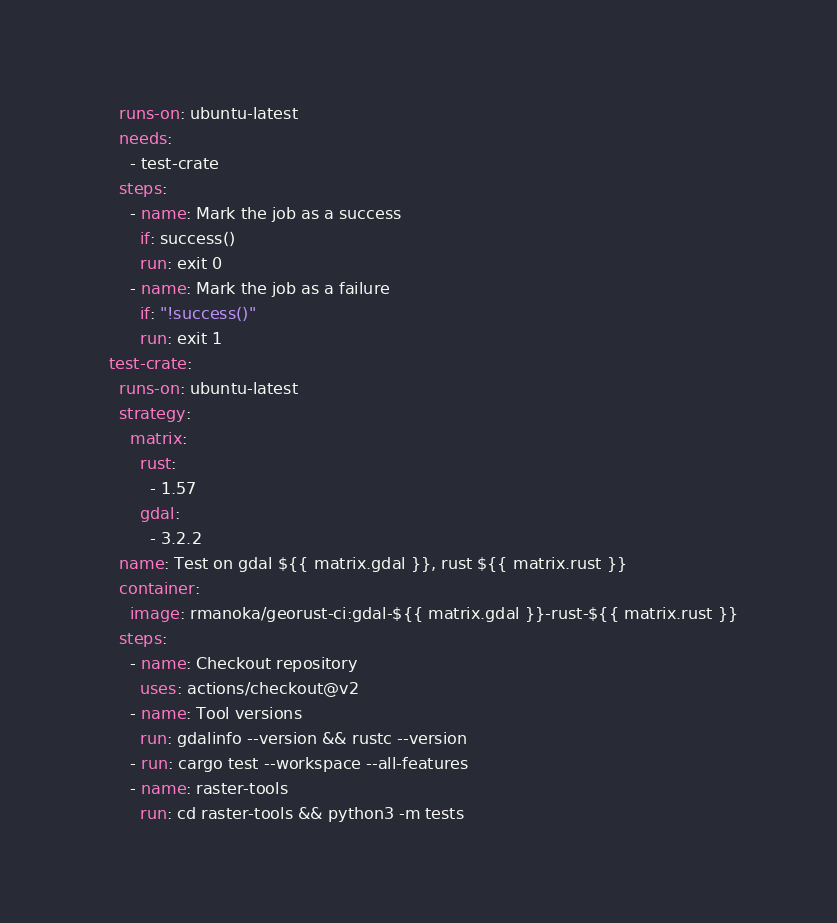<code> <loc_0><loc_0><loc_500><loc_500><_YAML_>    runs-on: ubuntu-latest
    needs:
      - test-crate
    steps:
      - name: Mark the job as a success
        if: success()
        run: exit 0
      - name: Mark the job as a failure
        if: "!success()"
        run: exit 1
  test-crate:
    runs-on: ubuntu-latest
    strategy:
      matrix:
        rust:
          - 1.57
        gdal:
          - 3.2.2
    name: Test on gdal ${{ matrix.gdal }}, rust ${{ matrix.rust }}
    container:
      image: rmanoka/georust-ci:gdal-${{ matrix.gdal }}-rust-${{ matrix.rust }}
    steps:
      - name: Checkout repository
        uses: actions/checkout@v2
      - name: Tool versions
        run: gdalinfo --version && rustc --version
      - run: cargo test --workspace --all-features
      - name: raster-tools
        run: cd raster-tools && python3 -m tests
</code> 